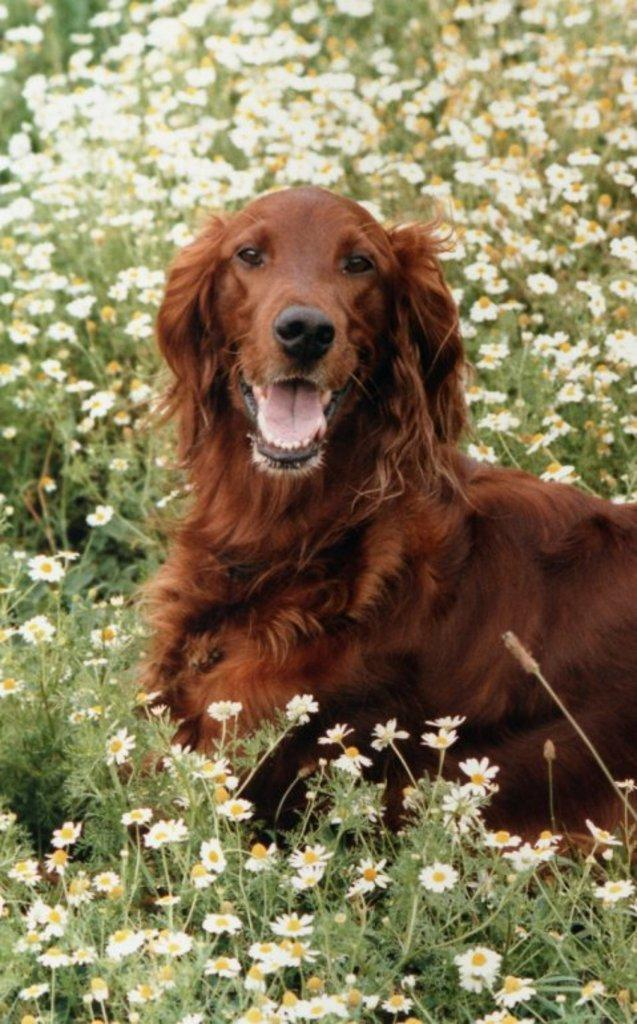What type of animal is in the image? There is a dog in the image. Where is the dog located? The dog is on the land. What can be seen in the background of the image? There are plants in the background of the image. What features do the plants have? The plants have flowers and leaves. What type of bean is growing on the dog in the image? There are no beans present in the image, and the dog is not associated with any bean plants. How many goldfish can be seen swimming in the image? There are no goldfish present in the image. 